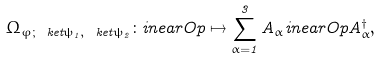<formula> <loc_0><loc_0><loc_500><loc_500>\Omega _ { \varphi ; \ k e t { \psi _ { 1 } } , \ k e t { \psi _ { 2 } } } \colon \L i n e a r O p \mapsto \sum _ { \alpha = 1 } ^ { 3 } A _ { \alpha } \L i n e a r O p A _ { \alpha } ^ { \dag } ,</formula> 